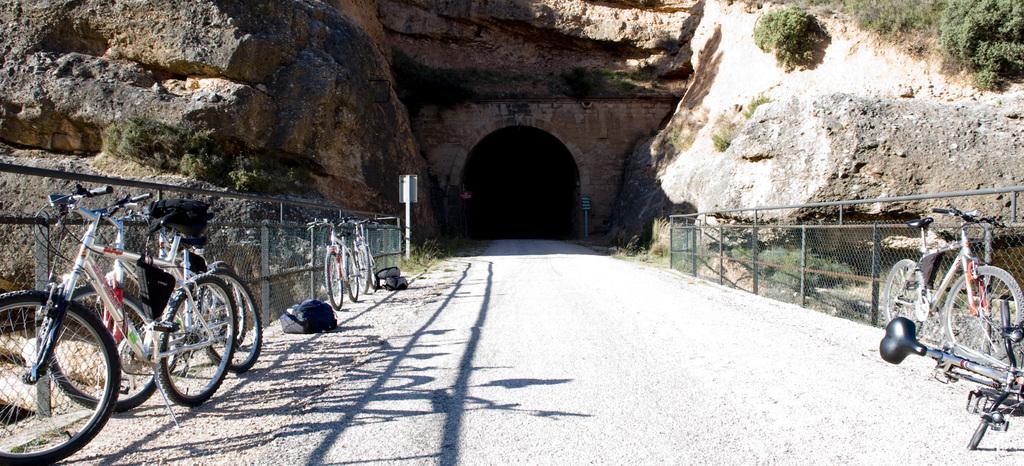How would you summarize this image in a sentence or two? In this image we can see a tunnel in the hill, trees, fences, bicycles on the road and bags. 